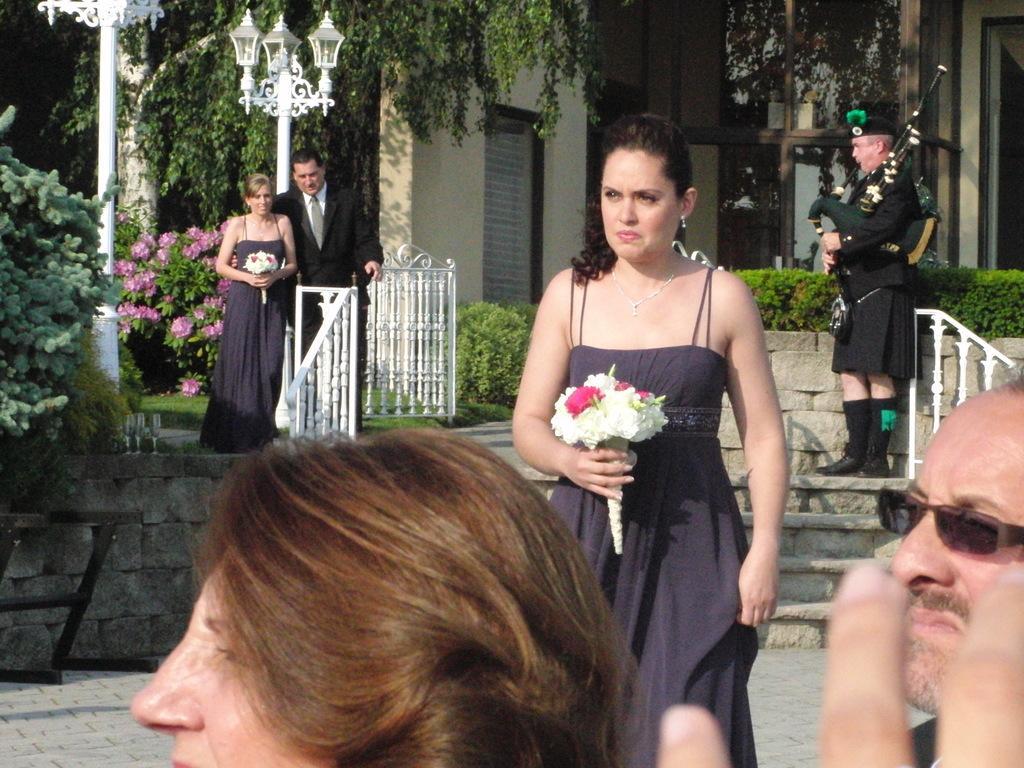How would you summarize this image in a sentence or two? In this image we can see a few people, two ladies are holding flower bouquets, a man is playing a bagpipe, there are plants, trees, flowers, there is a staircase, handrails, also we can see a house. 